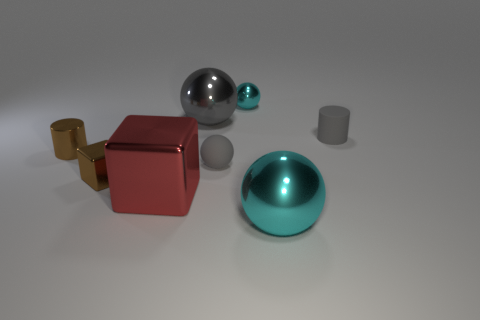Add 1 big red things. How many objects exist? 9 Subtract all cubes. How many objects are left? 6 Subtract all large blue rubber blocks. Subtract all large red cubes. How many objects are left? 7 Add 8 gray balls. How many gray balls are left? 10 Add 8 big spheres. How many big spheres exist? 10 Subtract 0 purple cylinders. How many objects are left? 8 